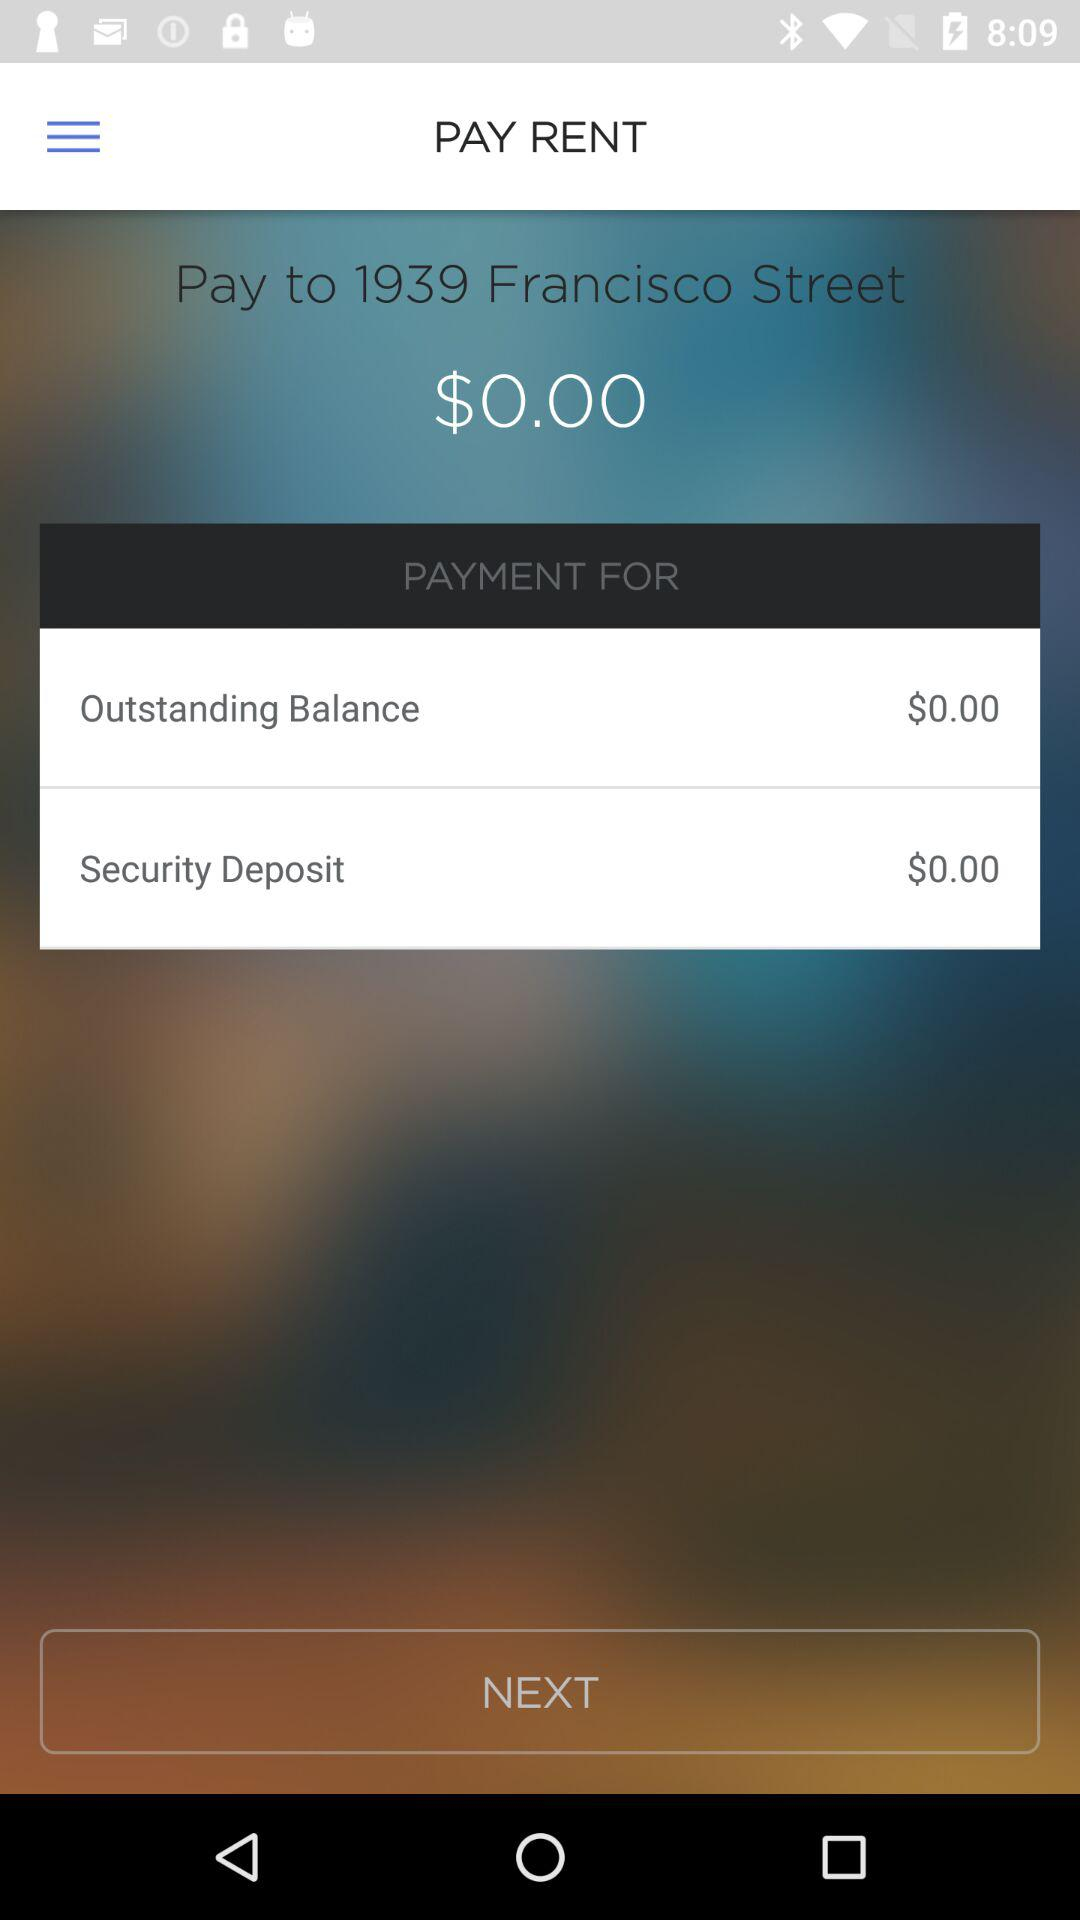How much is the outstanding balance?
Answer the question using a single word or phrase. $0.00 